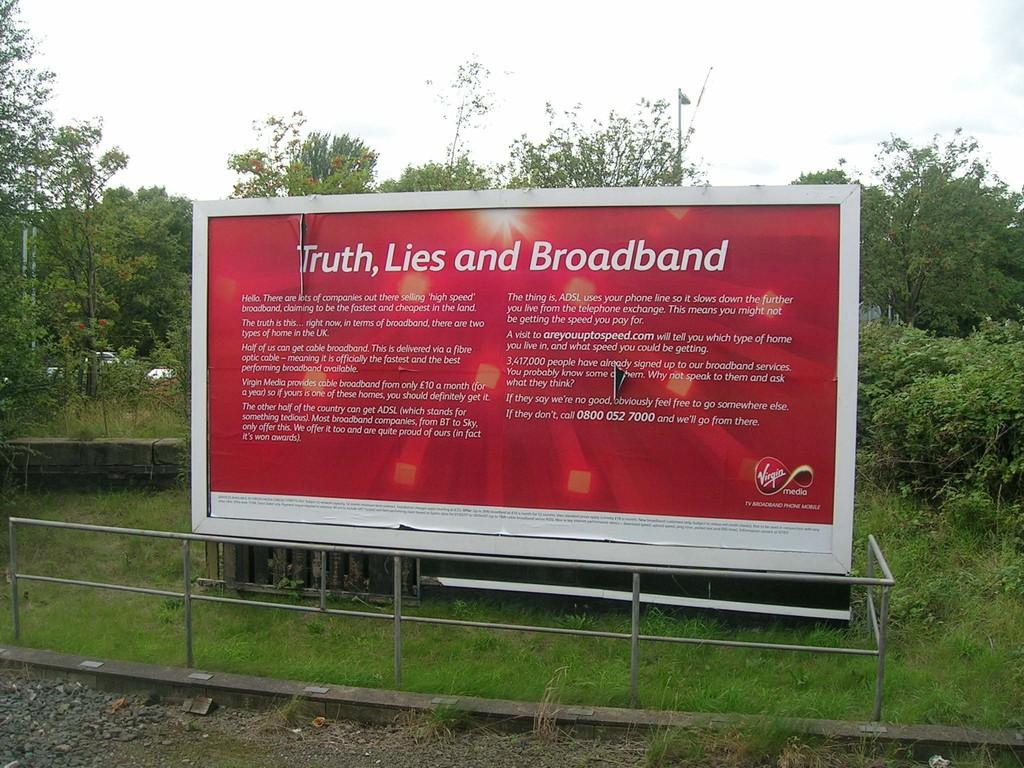What is on the board that is visible in the image? There are words written on the board in the image. What type of natural environment is visible in the image? There is green grass visible in the image. What type of structure is present in the image? There is railing in the image. What can be seen in the background of the image? There are trees and the sky visible in the background of the image. How many boats are visible in the image? There are no boats present in the image. What type of stage is set up for the performance in the image? There is no stage present in the image; it features a board with words, green grass, railing, trees, and the sky. 